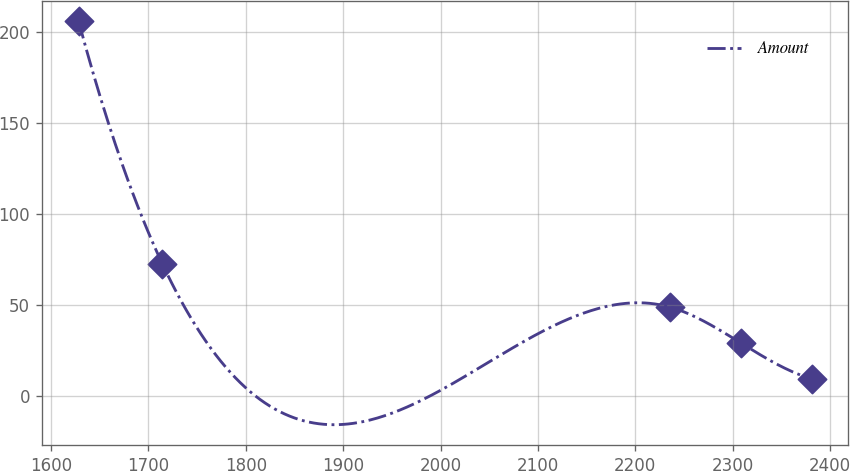Convert chart to OTSL. <chart><loc_0><loc_0><loc_500><loc_500><line_chart><ecel><fcel>Amount<nl><fcel>1628.12<fcel>206.1<nl><fcel>1714.12<fcel>72.62<nl><fcel>2235.6<fcel>48.7<nl><fcel>2308.31<fcel>29.02<nl><fcel>2381.02<fcel>9.34<nl></chart> 